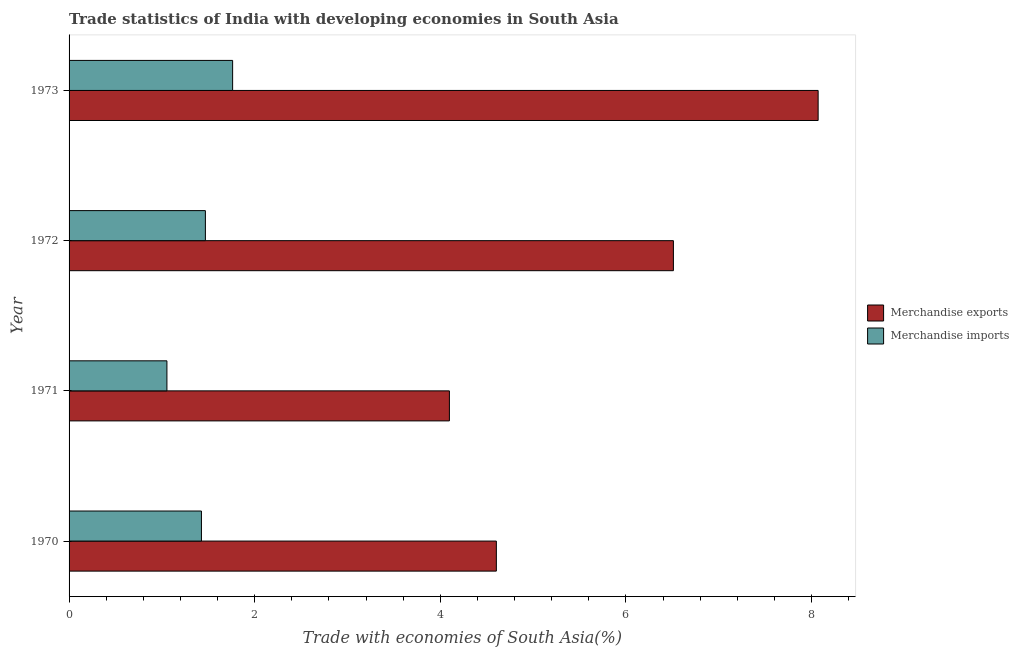How many groups of bars are there?
Keep it short and to the point. 4. Are the number of bars on each tick of the Y-axis equal?
Your answer should be very brief. Yes. How many bars are there on the 3rd tick from the top?
Provide a short and direct response. 2. How many bars are there on the 3rd tick from the bottom?
Keep it short and to the point. 2. In how many cases, is the number of bars for a given year not equal to the number of legend labels?
Your answer should be compact. 0. What is the merchandise imports in 1972?
Keep it short and to the point. 1.47. Across all years, what is the maximum merchandise imports?
Ensure brevity in your answer.  1.76. Across all years, what is the minimum merchandise imports?
Your answer should be compact. 1.05. In which year was the merchandise exports minimum?
Your answer should be compact. 1971. What is the total merchandise imports in the graph?
Offer a terse response. 5.71. What is the difference between the merchandise exports in 1970 and that in 1972?
Offer a very short reply. -1.91. What is the difference between the merchandise imports in 1973 and the merchandise exports in 1970?
Offer a very short reply. -2.84. What is the average merchandise imports per year?
Keep it short and to the point. 1.43. In the year 1971, what is the difference between the merchandise imports and merchandise exports?
Provide a succinct answer. -3.04. In how many years, is the merchandise exports greater than 6 %?
Provide a succinct answer. 2. What is the ratio of the merchandise imports in 1971 to that in 1972?
Ensure brevity in your answer.  0.72. Is the merchandise imports in 1972 less than that in 1973?
Provide a short and direct response. Yes. What is the difference between the highest and the second highest merchandise imports?
Make the answer very short. 0.29. What is the difference between the highest and the lowest merchandise imports?
Your response must be concise. 0.71. In how many years, is the merchandise imports greater than the average merchandise imports taken over all years?
Make the answer very short. 2. Is the sum of the merchandise imports in 1972 and 1973 greater than the maximum merchandise exports across all years?
Keep it short and to the point. No. What does the 2nd bar from the bottom in 1971 represents?
Provide a succinct answer. Merchandise imports. How many bars are there?
Make the answer very short. 8. How many years are there in the graph?
Ensure brevity in your answer.  4. Does the graph contain any zero values?
Keep it short and to the point. No. How are the legend labels stacked?
Offer a terse response. Vertical. What is the title of the graph?
Your answer should be very brief. Trade statistics of India with developing economies in South Asia. What is the label or title of the X-axis?
Offer a terse response. Trade with economies of South Asia(%). What is the Trade with economies of South Asia(%) of Merchandise exports in 1970?
Provide a short and direct response. 4.6. What is the Trade with economies of South Asia(%) in Merchandise imports in 1970?
Offer a terse response. 1.43. What is the Trade with economies of South Asia(%) of Merchandise exports in 1971?
Ensure brevity in your answer.  4.1. What is the Trade with economies of South Asia(%) in Merchandise imports in 1971?
Keep it short and to the point. 1.05. What is the Trade with economies of South Asia(%) of Merchandise exports in 1972?
Provide a short and direct response. 6.51. What is the Trade with economies of South Asia(%) in Merchandise imports in 1972?
Give a very brief answer. 1.47. What is the Trade with economies of South Asia(%) in Merchandise exports in 1973?
Give a very brief answer. 8.07. What is the Trade with economies of South Asia(%) in Merchandise imports in 1973?
Your answer should be compact. 1.76. Across all years, what is the maximum Trade with economies of South Asia(%) of Merchandise exports?
Offer a very short reply. 8.07. Across all years, what is the maximum Trade with economies of South Asia(%) of Merchandise imports?
Make the answer very short. 1.76. Across all years, what is the minimum Trade with economies of South Asia(%) in Merchandise exports?
Keep it short and to the point. 4.1. Across all years, what is the minimum Trade with economies of South Asia(%) of Merchandise imports?
Make the answer very short. 1.05. What is the total Trade with economies of South Asia(%) of Merchandise exports in the graph?
Provide a succinct answer. 23.28. What is the total Trade with economies of South Asia(%) in Merchandise imports in the graph?
Give a very brief answer. 5.71. What is the difference between the Trade with economies of South Asia(%) in Merchandise exports in 1970 and that in 1971?
Keep it short and to the point. 0.51. What is the difference between the Trade with economies of South Asia(%) in Merchandise imports in 1970 and that in 1971?
Your answer should be very brief. 0.37. What is the difference between the Trade with economies of South Asia(%) in Merchandise exports in 1970 and that in 1972?
Your answer should be very brief. -1.91. What is the difference between the Trade with economies of South Asia(%) of Merchandise imports in 1970 and that in 1972?
Give a very brief answer. -0.04. What is the difference between the Trade with economies of South Asia(%) in Merchandise exports in 1970 and that in 1973?
Provide a succinct answer. -3.47. What is the difference between the Trade with economies of South Asia(%) of Merchandise imports in 1970 and that in 1973?
Provide a succinct answer. -0.34. What is the difference between the Trade with economies of South Asia(%) in Merchandise exports in 1971 and that in 1972?
Offer a very short reply. -2.41. What is the difference between the Trade with economies of South Asia(%) in Merchandise imports in 1971 and that in 1972?
Offer a very short reply. -0.41. What is the difference between the Trade with economies of South Asia(%) of Merchandise exports in 1971 and that in 1973?
Offer a terse response. -3.97. What is the difference between the Trade with economies of South Asia(%) in Merchandise imports in 1971 and that in 1973?
Ensure brevity in your answer.  -0.71. What is the difference between the Trade with economies of South Asia(%) in Merchandise exports in 1972 and that in 1973?
Give a very brief answer. -1.56. What is the difference between the Trade with economies of South Asia(%) of Merchandise imports in 1972 and that in 1973?
Your response must be concise. -0.29. What is the difference between the Trade with economies of South Asia(%) in Merchandise exports in 1970 and the Trade with economies of South Asia(%) in Merchandise imports in 1971?
Keep it short and to the point. 3.55. What is the difference between the Trade with economies of South Asia(%) of Merchandise exports in 1970 and the Trade with economies of South Asia(%) of Merchandise imports in 1972?
Offer a terse response. 3.13. What is the difference between the Trade with economies of South Asia(%) in Merchandise exports in 1970 and the Trade with economies of South Asia(%) in Merchandise imports in 1973?
Your response must be concise. 2.84. What is the difference between the Trade with economies of South Asia(%) in Merchandise exports in 1971 and the Trade with economies of South Asia(%) in Merchandise imports in 1972?
Your response must be concise. 2.63. What is the difference between the Trade with economies of South Asia(%) in Merchandise exports in 1971 and the Trade with economies of South Asia(%) in Merchandise imports in 1973?
Provide a short and direct response. 2.34. What is the difference between the Trade with economies of South Asia(%) in Merchandise exports in 1972 and the Trade with economies of South Asia(%) in Merchandise imports in 1973?
Your answer should be very brief. 4.75. What is the average Trade with economies of South Asia(%) of Merchandise exports per year?
Your answer should be compact. 5.82. What is the average Trade with economies of South Asia(%) in Merchandise imports per year?
Provide a succinct answer. 1.43. In the year 1970, what is the difference between the Trade with economies of South Asia(%) of Merchandise exports and Trade with economies of South Asia(%) of Merchandise imports?
Provide a short and direct response. 3.18. In the year 1971, what is the difference between the Trade with economies of South Asia(%) in Merchandise exports and Trade with economies of South Asia(%) in Merchandise imports?
Your answer should be very brief. 3.04. In the year 1972, what is the difference between the Trade with economies of South Asia(%) in Merchandise exports and Trade with economies of South Asia(%) in Merchandise imports?
Offer a terse response. 5.04. In the year 1973, what is the difference between the Trade with economies of South Asia(%) in Merchandise exports and Trade with economies of South Asia(%) in Merchandise imports?
Offer a terse response. 6.31. What is the ratio of the Trade with economies of South Asia(%) in Merchandise exports in 1970 to that in 1971?
Your response must be concise. 1.12. What is the ratio of the Trade with economies of South Asia(%) of Merchandise imports in 1970 to that in 1971?
Your answer should be compact. 1.35. What is the ratio of the Trade with economies of South Asia(%) of Merchandise exports in 1970 to that in 1972?
Offer a terse response. 0.71. What is the ratio of the Trade with economies of South Asia(%) in Merchandise imports in 1970 to that in 1972?
Give a very brief answer. 0.97. What is the ratio of the Trade with economies of South Asia(%) in Merchandise exports in 1970 to that in 1973?
Your answer should be compact. 0.57. What is the ratio of the Trade with economies of South Asia(%) in Merchandise imports in 1970 to that in 1973?
Your response must be concise. 0.81. What is the ratio of the Trade with economies of South Asia(%) of Merchandise exports in 1971 to that in 1972?
Make the answer very short. 0.63. What is the ratio of the Trade with economies of South Asia(%) in Merchandise imports in 1971 to that in 1972?
Provide a succinct answer. 0.72. What is the ratio of the Trade with economies of South Asia(%) of Merchandise exports in 1971 to that in 1973?
Keep it short and to the point. 0.51. What is the ratio of the Trade with economies of South Asia(%) in Merchandise imports in 1971 to that in 1973?
Make the answer very short. 0.6. What is the ratio of the Trade with economies of South Asia(%) of Merchandise exports in 1972 to that in 1973?
Provide a succinct answer. 0.81. What is the ratio of the Trade with economies of South Asia(%) in Merchandise imports in 1972 to that in 1973?
Your answer should be very brief. 0.83. What is the difference between the highest and the second highest Trade with economies of South Asia(%) in Merchandise exports?
Keep it short and to the point. 1.56. What is the difference between the highest and the second highest Trade with economies of South Asia(%) in Merchandise imports?
Offer a terse response. 0.29. What is the difference between the highest and the lowest Trade with economies of South Asia(%) in Merchandise exports?
Give a very brief answer. 3.97. What is the difference between the highest and the lowest Trade with economies of South Asia(%) in Merchandise imports?
Provide a succinct answer. 0.71. 